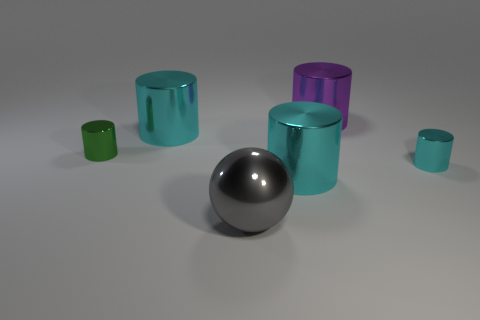Add 1 large cyan objects. How many objects exist? 7 Subtract all large cyan cylinders. How many cylinders are left? 3 Subtract all gray balls. How many cyan cylinders are left? 3 Subtract all green cylinders. How many cylinders are left? 4 Subtract all cylinders. How many objects are left? 1 Add 5 purple things. How many purple things are left? 6 Add 1 tiny gray cylinders. How many tiny gray cylinders exist? 1 Subtract 0 brown blocks. How many objects are left? 6 Subtract all brown spheres. Subtract all blue cylinders. How many spheres are left? 1 Subtract all big cyan cylinders. Subtract all tiny green metallic objects. How many objects are left? 3 